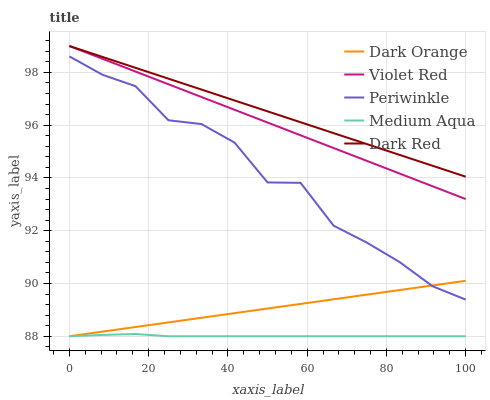Does Medium Aqua have the minimum area under the curve?
Answer yes or no. Yes. Does Dark Red have the maximum area under the curve?
Answer yes or no. Yes. Does Dark Orange have the minimum area under the curve?
Answer yes or no. No. Does Dark Orange have the maximum area under the curve?
Answer yes or no. No. Is Dark Red the smoothest?
Answer yes or no. Yes. Is Periwinkle the roughest?
Answer yes or no. Yes. Is Dark Orange the smoothest?
Answer yes or no. No. Is Dark Orange the roughest?
Answer yes or no. No. Does Medium Aqua have the lowest value?
Answer yes or no. Yes. Does Violet Red have the lowest value?
Answer yes or no. No. Does Dark Red have the highest value?
Answer yes or no. Yes. Does Dark Orange have the highest value?
Answer yes or no. No. Is Periwinkle less than Violet Red?
Answer yes or no. Yes. Is Dark Red greater than Dark Orange?
Answer yes or no. Yes. Does Violet Red intersect Dark Red?
Answer yes or no. Yes. Is Violet Red less than Dark Red?
Answer yes or no. No. Is Violet Red greater than Dark Red?
Answer yes or no. No. Does Periwinkle intersect Violet Red?
Answer yes or no. No. 